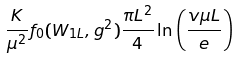<formula> <loc_0><loc_0><loc_500><loc_500>\frac { K } { \mu ^ { 2 } } f _ { 0 } ( W _ { 1 L } , g ^ { 2 } ) \frac { \pi L ^ { 2 } } { 4 } \ln \left ( \frac { v \mu L } { e } \right )</formula> 